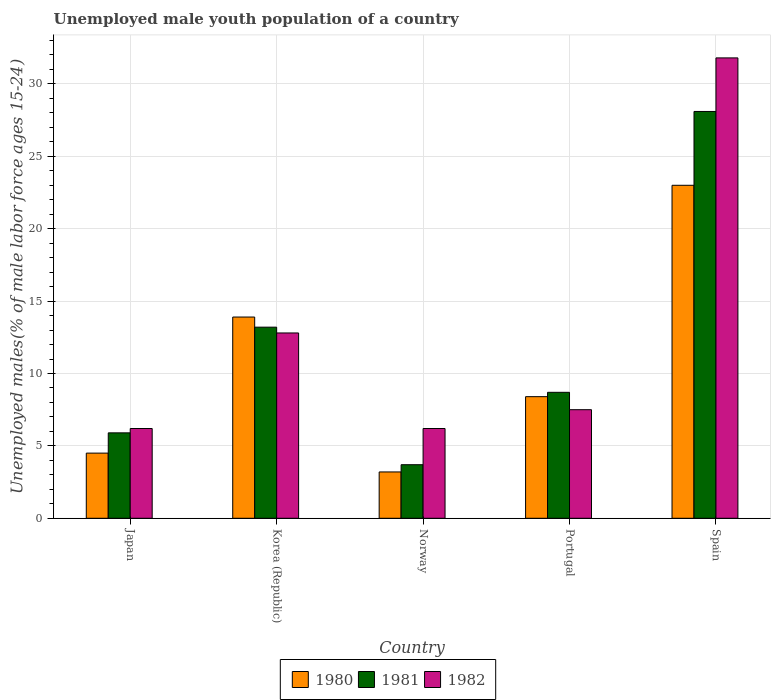How many different coloured bars are there?
Your response must be concise. 3. How many groups of bars are there?
Provide a succinct answer. 5. Are the number of bars on each tick of the X-axis equal?
Your response must be concise. Yes. How many bars are there on the 3rd tick from the right?
Offer a very short reply. 3. In how many cases, is the number of bars for a given country not equal to the number of legend labels?
Offer a very short reply. 0. What is the percentage of unemployed male youth population in 1981 in Korea (Republic)?
Make the answer very short. 13.2. Across all countries, what is the maximum percentage of unemployed male youth population in 1981?
Make the answer very short. 28.1. Across all countries, what is the minimum percentage of unemployed male youth population in 1981?
Provide a succinct answer. 3.7. In which country was the percentage of unemployed male youth population in 1982 maximum?
Make the answer very short. Spain. In which country was the percentage of unemployed male youth population in 1980 minimum?
Give a very brief answer. Norway. What is the total percentage of unemployed male youth population in 1982 in the graph?
Provide a short and direct response. 64.5. What is the difference between the percentage of unemployed male youth population in 1980 in Japan and that in Spain?
Ensure brevity in your answer.  -18.5. What is the difference between the percentage of unemployed male youth population in 1980 in Portugal and the percentage of unemployed male youth population in 1982 in Spain?
Offer a very short reply. -23.4. What is the average percentage of unemployed male youth population in 1980 per country?
Offer a terse response. 10.6. What is the difference between the percentage of unemployed male youth population of/in 1980 and percentage of unemployed male youth population of/in 1981 in Norway?
Offer a very short reply. -0.5. What is the ratio of the percentage of unemployed male youth population in 1982 in Korea (Republic) to that in Norway?
Provide a succinct answer. 2.06. What is the difference between the highest and the second highest percentage of unemployed male youth population in 1981?
Your answer should be compact. -19.4. What is the difference between the highest and the lowest percentage of unemployed male youth population in 1981?
Your answer should be very brief. 24.4. In how many countries, is the percentage of unemployed male youth population in 1982 greater than the average percentage of unemployed male youth population in 1982 taken over all countries?
Your response must be concise. 1. Is the sum of the percentage of unemployed male youth population in 1980 in Japan and Norway greater than the maximum percentage of unemployed male youth population in 1982 across all countries?
Your answer should be very brief. No. Is it the case that in every country, the sum of the percentage of unemployed male youth population in 1980 and percentage of unemployed male youth population in 1982 is greater than the percentage of unemployed male youth population in 1981?
Ensure brevity in your answer.  Yes. How many bars are there?
Your answer should be compact. 15. How many countries are there in the graph?
Give a very brief answer. 5. What is the difference between two consecutive major ticks on the Y-axis?
Give a very brief answer. 5. Does the graph contain any zero values?
Provide a succinct answer. No. What is the title of the graph?
Your response must be concise. Unemployed male youth population of a country. Does "2000" appear as one of the legend labels in the graph?
Give a very brief answer. No. What is the label or title of the X-axis?
Offer a very short reply. Country. What is the label or title of the Y-axis?
Keep it short and to the point. Unemployed males(% of male labor force ages 15-24). What is the Unemployed males(% of male labor force ages 15-24) of 1981 in Japan?
Give a very brief answer. 5.9. What is the Unemployed males(% of male labor force ages 15-24) in 1982 in Japan?
Make the answer very short. 6.2. What is the Unemployed males(% of male labor force ages 15-24) of 1980 in Korea (Republic)?
Keep it short and to the point. 13.9. What is the Unemployed males(% of male labor force ages 15-24) of 1981 in Korea (Republic)?
Your response must be concise. 13.2. What is the Unemployed males(% of male labor force ages 15-24) of 1982 in Korea (Republic)?
Give a very brief answer. 12.8. What is the Unemployed males(% of male labor force ages 15-24) of 1980 in Norway?
Offer a very short reply. 3.2. What is the Unemployed males(% of male labor force ages 15-24) in 1981 in Norway?
Your response must be concise. 3.7. What is the Unemployed males(% of male labor force ages 15-24) in 1982 in Norway?
Offer a very short reply. 6.2. What is the Unemployed males(% of male labor force ages 15-24) of 1980 in Portugal?
Ensure brevity in your answer.  8.4. What is the Unemployed males(% of male labor force ages 15-24) in 1981 in Portugal?
Provide a short and direct response. 8.7. What is the Unemployed males(% of male labor force ages 15-24) of 1981 in Spain?
Provide a short and direct response. 28.1. What is the Unemployed males(% of male labor force ages 15-24) in 1982 in Spain?
Your answer should be very brief. 31.8. Across all countries, what is the maximum Unemployed males(% of male labor force ages 15-24) in 1981?
Keep it short and to the point. 28.1. Across all countries, what is the maximum Unemployed males(% of male labor force ages 15-24) in 1982?
Give a very brief answer. 31.8. Across all countries, what is the minimum Unemployed males(% of male labor force ages 15-24) of 1980?
Provide a short and direct response. 3.2. Across all countries, what is the minimum Unemployed males(% of male labor force ages 15-24) of 1981?
Your response must be concise. 3.7. Across all countries, what is the minimum Unemployed males(% of male labor force ages 15-24) of 1982?
Ensure brevity in your answer.  6.2. What is the total Unemployed males(% of male labor force ages 15-24) of 1981 in the graph?
Keep it short and to the point. 59.6. What is the total Unemployed males(% of male labor force ages 15-24) of 1982 in the graph?
Your answer should be very brief. 64.5. What is the difference between the Unemployed males(% of male labor force ages 15-24) of 1980 in Japan and that in Korea (Republic)?
Your answer should be very brief. -9.4. What is the difference between the Unemployed males(% of male labor force ages 15-24) in 1982 in Japan and that in Korea (Republic)?
Your response must be concise. -6.6. What is the difference between the Unemployed males(% of male labor force ages 15-24) of 1980 in Japan and that in Norway?
Provide a succinct answer. 1.3. What is the difference between the Unemployed males(% of male labor force ages 15-24) in 1982 in Japan and that in Norway?
Offer a very short reply. 0. What is the difference between the Unemployed males(% of male labor force ages 15-24) of 1981 in Japan and that in Portugal?
Keep it short and to the point. -2.8. What is the difference between the Unemployed males(% of male labor force ages 15-24) of 1980 in Japan and that in Spain?
Provide a short and direct response. -18.5. What is the difference between the Unemployed males(% of male labor force ages 15-24) in 1981 in Japan and that in Spain?
Give a very brief answer. -22.2. What is the difference between the Unemployed males(% of male labor force ages 15-24) of 1982 in Japan and that in Spain?
Make the answer very short. -25.6. What is the difference between the Unemployed males(% of male labor force ages 15-24) in 1980 in Korea (Republic) and that in Norway?
Offer a terse response. 10.7. What is the difference between the Unemployed males(% of male labor force ages 15-24) of 1981 in Korea (Republic) and that in Portugal?
Your answer should be compact. 4.5. What is the difference between the Unemployed males(% of male labor force ages 15-24) of 1982 in Korea (Republic) and that in Portugal?
Make the answer very short. 5.3. What is the difference between the Unemployed males(% of male labor force ages 15-24) in 1981 in Korea (Republic) and that in Spain?
Ensure brevity in your answer.  -14.9. What is the difference between the Unemployed males(% of male labor force ages 15-24) of 1982 in Korea (Republic) and that in Spain?
Your response must be concise. -19. What is the difference between the Unemployed males(% of male labor force ages 15-24) in 1981 in Norway and that in Portugal?
Your response must be concise. -5. What is the difference between the Unemployed males(% of male labor force ages 15-24) of 1980 in Norway and that in Spain?
Make the answer very short. -19.8. What is the difference between the Unemployed males(% of male labor force ages 15-24) of 1981 in Norway and that in Spain?
Your answer should be very brief. -24.4. What is the difference between the Unemployed males(% of male labor force ages 15-24) of 1982 in Norway and that in Spain?
Provide a succinct answer. -25.6. What is the difference between the Unemployed males(% of male labor force ages 15-24) of 1980 in Portugal and that in Spain?
Keep it short and to the point. -14.6. What is the difference between the Unemployed males(% of male labor force ages 15-24) in 1981 in Portugal and that in Spain?
Keep it short and to the point. -19.4. What is the difference between the Unemployed males(% of male labor force ages 15-24) of 1982 in Portugal and that in Spain?
Ensure brevity in your answer.  -24.3. What is the difference between the Unemployed males(% of male labor force ages 15-24) of 1980 in Japan and the Unemployed males(% of male labor force ages 15-24) of 1982 in Korea (Republic)?
Your answer should be very brief. -8.3. What is the difference between the Unemployed males(% of male labor force ages 15-24) in 1980 in Japan and the Unemployed males(% of male labor force ages 15-24) in 1981 in Norway?
Make the answer very short. 0.8. What is the difference between the Unemployed males(% of male labor force ages 15-24) of 1980 in Japan and the Unemployed males(% of male labor force ages 15-24) of 1982 in Norway?
Your answer should be very brief. -1.7. What is the difference between the Unemployed males(% of male labor force ages 15-24) of 1980 in Japan and the Unemployed males(% of male labor force ages 15-24) of 1981 in Portugal?
Keep it short and to the point. -4.2. What is the difference between the Unemployed males(% of male labor force ages 15-24) in 1980 in Japan and the Unemployed males(% of male labor force ages 15-24) in 1981 in Spain?
Make the answer very short. -23.6. What is the difference between the Unemployed males(% of male labor force ages 15-24) of 1980 in Japan and the Unemployed males(% of male labor force ages 15-24) of 1982 in Spain?
Your response must be concise. -27.3. What is the difference between the Unemployed males(% of male labor force ages 15-24) in 1981 in Japan and the Unemployed males(% of male labor force ages 15-24) in 1982 in Spain?
Offer a very short reply. -25.9. What is the difference between the Unemployed males(% of male labor force ages 15-24) of 1980 in Korea (Republic) and the Unemployed males(% of male labor force ages 15-24) of 1982 in Norway?
Provide a short and direct response. 7.7. What is the difference between the Unemployed males(% of male labor force ages 15-24) of 1981 in Korea (Republic) and the Unemployed males(% of male labor force ages 15-24) of 1982 in Norway?
Your answer should be very brief. 7. What is the difference between the Unemployed males(% of male labor force ages 15-24) in 1980 in Korea (Republic) and the Unemployed males(% of male labor force ages 15-24) in 1981 in Portugal?
Offer a terse response. 5.2. What is the difference between the Unemployed males(% of male labor force ages 15-24) of 1981 in Korea (Republic) and the Unemployed males(% of male labor force ages 15-24) of 1982 in Portugal?
Ensure brevity in your answer.  5.7. What is the difference between the Unemployed males(% of male labor force ages 15-24) of 1980 in Korea (Republic) and the Unemployed males(% of male labor force ages 15-24) of 1981 in Spain?
Provide a succinct answer. -14.2. What is the difference between the Unemployed males(% of male labor force ages 15-24) of 1980 in Korea (Republic) and the Unemployed males(% of male labor force ages 15-24) of 1982 in Spain?
Give a very brief answer. -17.9. What is the difference between the Unemployed males(% of male labor force ages 15-24) in 1981 in Korea (Republic) and the Unemployed males(% of male labor force ages 15-24) in 1982 in Spain?
Your response must be concise. -18.6. What is the difference between the Unemployed males(% of male labor force ages 15-24) in 1980 in Norway and the Unemployed males(% of male labor force ages 15-24) in 1982 in Portugal?
Keep it short and to the point. -4.3. What is the difference between the Unemployed males(% of male labor force ages 15-24) in 1980 in Norway and the Unemployed males(% of male labor force ages 15-24) in 1981 in Spain?
Make the answer very short. -24.9. What is the difference between the Unemployed males(% of male labor force ages 15-24) in 1980 in Norway and the Unemployed males(% of male labor force ages 15-24) in 1982 in Spain?
Make the answer very short. -28.6. What is the difference between the Unemployed males(% of male labor force ages 15-24) in 1981 in Norway and the Unemployed males(% of male labor force ages 15-24) in 1982 in Spain?
Keep it short and to the point. -28.1. What is the difference between the Unemployed males(% of male labor force ages 15-24) in 1980 in Portugal and the Unemployed males(% of male labor force ages 15-24) in 1981 in Spain?
Your answer should be compact. -19.7. What is the difference between the Unemployed males(% of male labor force ages 15-24) in 1980 in Portugal and the Unemployed males(% of male labor force ages 15-24) in 1982 in Spain?
Ensure brevity in your answer.  -23.4. What is the difference between the Unemployed males(% of male labor force ages 15-24) of 1981 in Portugal and the Unemployed males(% of male labor force ages 15-24) of 1982 in Spain?
Provide a short and direct response. -23.1. What is the average Unemployed males(% of male labor force ages 15-24) of 1981 per country?
Offer a terse response. 11.92. What is the average Unemployed males(% of male labor force ages 15-24) in 1982 per country?
Provide a succinct answer. 12.9. What is the difference between the Unemployed males(% of male labor force ages 15-24) in 1981 and Unemployed males(% of male labor force ages 15-24) in 1982 in Japan?
Your response must be concise. -0.3. What is the difference between the Unemployed males(% of male labor force ages 15-24) of 1980 and Unemployed males(% of male labor force ages 15-24) of 1981 in Korea (Republic)?
Your response must be concise. 0.7. What is the difference between the Unemployed males(% of male labor force ages 15-24) in 1980 and Unemployed males(% of male labor force ages 15-24) in 1981 in Norway?
Your response must be concise. -0.5. What is the difference between the Unemployed males(% of male labor force ages 15-24) in 1981 and Unemployed males(% of male labor force ages 15-24) in 1982 in Norway?
Give a very brief answer. -2.5. What is the difference between the Unemployed males(% of male labor force ages 15-24) of 1980 and Unemployed males(% of male labor force ages 15-24) of 1981 in Portugal?
Give a very brief answer. -0.3. What is the difference between the Unemployed males(% of male labor force ages 15-24) of 1980 and Unemployed males(% of male labor force ages 15-24) of 1982 in Portugal?
Keep it short and to the point. 0.9. What is the difference between the Unemployed males(% of male labor force ages 15-24) of 1981 and Unemployed males(% of male labor force ages 15-24) of 1982 in Portugal?
Offer a very short reply. 1.2. What is the difference between the Unemployed males(% of male labor force ages 15-24) in 1980 and Unemployed males(% of male labor force ages 15-24) in 1981 in Spain?
Ensure brevity in your answer.  -5.1. What is the difference between the Unemployed males(% of male labor force ages 15-24) in 1980 and Unemployed males(% of male labor force ages 15-24) in 1982 in Spain?
Make the answer very short. -8.8. What is the ratio of the Unemployed males(% of male labor force ages 15-24) of 1980 in Japan to that in Korea (Republic)?
Give a very brief answer. 0.32. What is the ratio of the Unemployed males(% of male labor force ages 15-24) of 1981 in Japan to that in Korea (Republic)?
Give a very brief answer. 0.45. What is the ratio of the Unemployed males(% of male labor force ages 15-24) of 1982 in Japan to that in Korea (Republic)?
Give a very brief answer. 0.48. What is the ratio of the Unemployed males(% of male labor force ages 15-24) in 1980 in Japan to that in Norway?
Provide a short and direct response. 1.41. What is the ratio of the Unemployed males(% of male labor force ages 15-24) of 1981 in Japan to that in Norway?
Ensure brevity in your answer.  1.59. What is the ratio of the Unemployed males(% of male labor force ages 15-24) of 1980 in Japan to that in Portugal?
Offer a terse response. 0.54. What is the ratio of the Unemployed males(% of male labor force ages 15-24) in 1981 in Japan to that in Portugal?
Provide a succinct answer. 0.68. What is the ratio of the Unemployed males(% of male labor force ages 15-24) in 1982 in Japan to that in Portugal?
Give a very brief answer. 0.83. What is the ratio of the Unemployed males(% of male labor force ages 15-24) in 1980 in Japan to that in Spain?
Give a very brief answer. 0.2. What is the ratio of the Unemployed males(% of male labor force ages 15-24) in 1981 in Japan to that in Spain?
Ensure brevity in your answer.  0.21. What is the ratio of the Unemployed males(% of male labor force ages 15-24) of 1982 in Japan to that in Spain?
Give a very brief answer. 0.2. What is the ratio of the Unemployed males(% of male labor force ages 15-24) in 1980 in Korea (Republic) to that in Norway?
Make the answer very short. 4.34. What is the ratio of the Unemployed males(% of male labor force ages 15-24) of 1981 in Korea (Republic) to that in Norway?
Provide a succinct answer. 3.57. What is the ratio of the Unemployed males(% of male labor force ages 15-24) of 1982 in Korea (Republic) to that in Norway?
Ensure brevity in your answer.  2.06. What is the ratio of the Unemployed males(% of male labor force ages 15-24) of 1980 in Korea (Republic) to that in Portugal?
Offer a terse response. 1.65. What is the ratio of the Unemployed males(% of male labor force ages 15-24) of 1981 in Korea (Republic) to that in Portugal?
Your answer should be very brief. 1.52. What is the ratio of the Unemployed males(% of male labor force ages 15-24) of 1982 in Korea (Republic) to that in Portugal?
Your answer should be very brief. 1.71. What is the ratio of the Unemployed males(% of male labor force ages 15-24) in 1980 in Korea (Republic) to that in Spain?
Give a very brief answer. 0.6. What is the ratio of the Unemployed males(% of male labor force ages 15-24) of 1981 in Korea (Republic) to that in Spain?
Give a very brief answer. 0.47. What is the ratio of the Unemployed males(% of male labor force ages 15-24) of 1982 in Korea (Republic) to that in Spain?
Provide a short and direct response. 0.4. What is the ratio of the Unemployed males(% of male labor force ages 15-24) in 1980 in Norway to that in Portugal?
Keep it short and to the point. 0.38. What is the ratio of the Unemployed males(% of male labor force ages 15-24) in 1981 in Norway to that in Portugal?
Provide a succinct answer. 0.43. What is the ratio of the Unemployed males(% of male labor force ages 15-24) of 1982 in Norway to that in Portugal?
Ensure brevity in your answer.  0.83. What is the ratio of the Unemployed males(% of male labor force ages 15-24) of 1980 in Norway to that in Spain?
Offer a terse response. 0.14. What is the ratio of the Unemployed males(% of male labor force ages 15-24) of 1981 in Norway to that in Spain?
Offer a very short reply. 0.13. What is the ratio of the Unemployed males(% of male labor force ages 15-24) of 1982 in Norway to that in Spain?
Offer a terse response. 0.2. What is the ratio of the Unemployed males(% of male labor force ages 15-24) of 1980 in Portugal to that in Spain?
Your answer should be very brief. 0.37. What is the ratio of the Unemployed males(% of male labor force ages 15-24) of 1981 in Portugal to that in Spain?
Offer a very short reply. 0.31. What is the ratio of the Unemployed males(% of male labor force ages 15-24) in 1982 in Portugal to that in Spain?
Keep it short and to the point. 0.24. What is the difference between the highest and the second highest Unemployed males(% of male labor force ages 15-24) in 1980?
Your answer should be very brief. 9.1. What is the difference between the highest and the second highest Unemployed males(% of male labor force ages 15-24) of 1982?
Offer a terse response. 19. What is the difference between the highest and the lowest Unemployed males(% of male labor force ages 15-24) in 1980?
Provide a succinct answer. 19.8. What is the difference between the highest and the lowest Unemployed males(% of male labor force ages 15-24) of 1981?
Offer a terse response. 24.4. What is the difference between the highest and the lowest Unemployed males(% of male labor force ages 15-24) in 1982?
Make the answer very short. 25.6. 